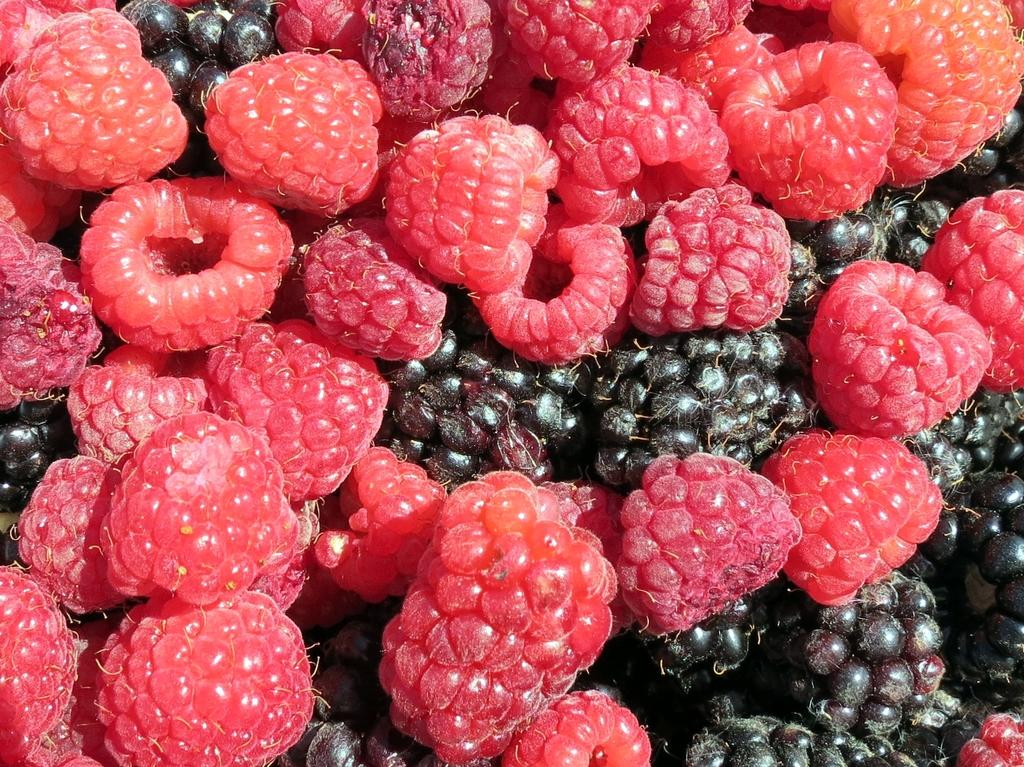What type of fruit or berry is present in the image? There are boysenberries in the image. What committee is responsible for organizing the boysenberries in the image? There is no committee present in the image, as it only features boysenberries. 